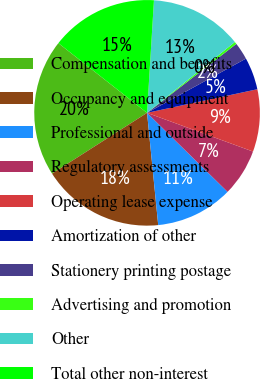Convert chart to OTSL. <chart><loc_0><loc_0><loc_500><loc_500><pie_chart><fcel>Compensation and benefits<fcel>Occupancy and equipment<fcel>Professional and outside<fcel>Regulatory assessments<fcel>Operating lease expense<fcel>Amortization of other<fcel>Stationery printing postage<fcel>Advertising and promotion<fcel>Other<fcel>Total other non-interest<nl><fcel>19.66%<fcel>17.52%<fcel>11.07%<fcel>6.78%<fcel>8.93%<fcel>4.63%<fcel>2.48%<fcel>0.34%<fcel>13.22%<fcel>15.37%<nl></chart> 